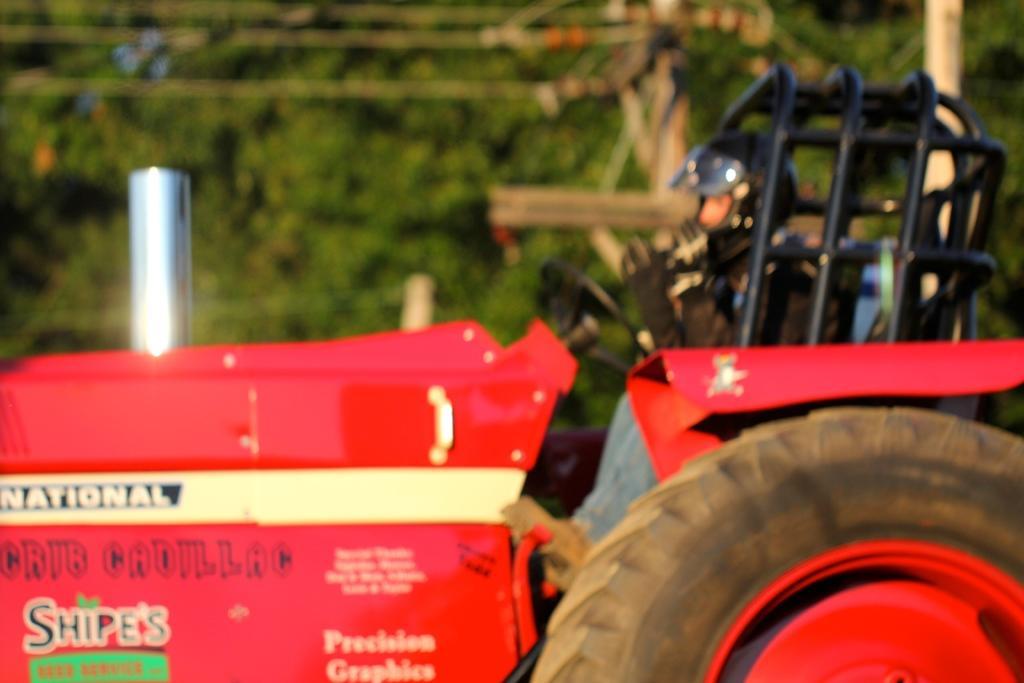How would you summarize this image in a sentence or two? In the image we can see there is a tractor on which a person is sitting. The person is wearing helmet, behind there are trees and the image is little blurry. 